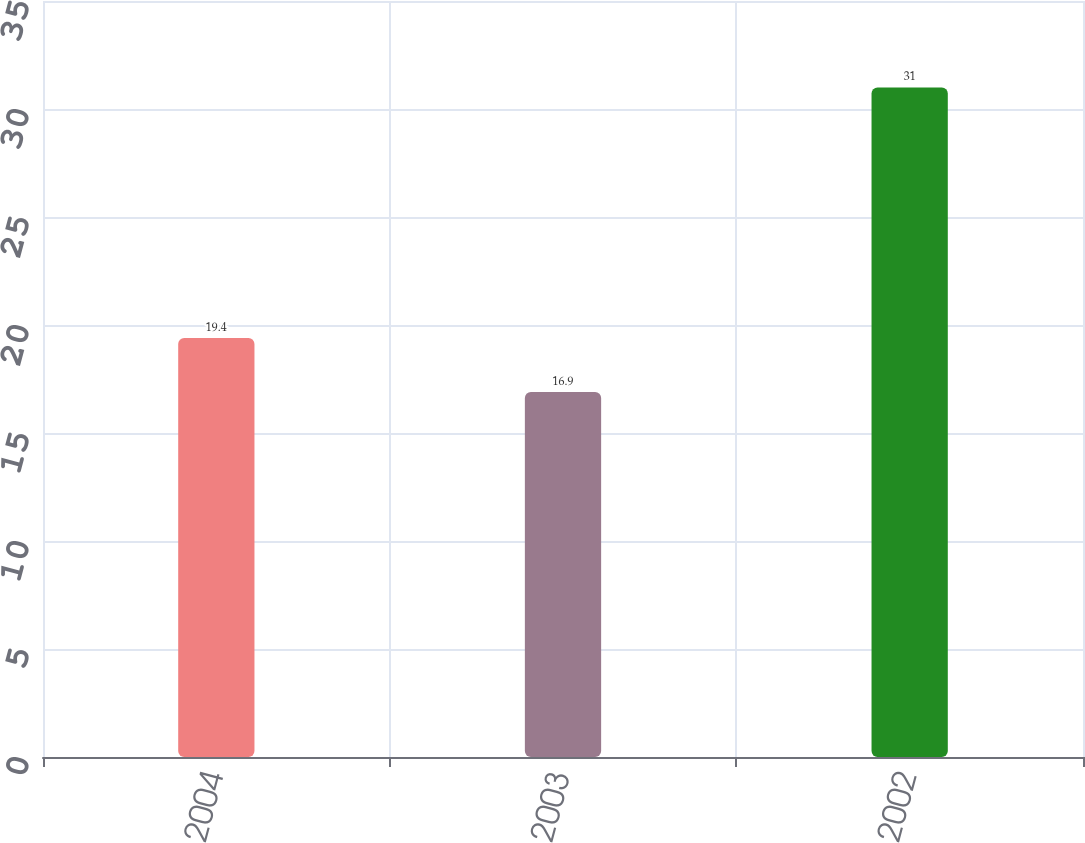<chart> <loc_0><loc_0><loc_500><loc_500><bar_chart><fcel>2004<fcel>2003<fcel>2002<nl><fcel>19.4<fcel>16.9<fcel>31<nl></chart> 